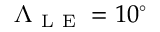<formula> <loc_0><loc_0><loc_500><loc_500>\Lambda _ { L E } = 1 0 ^ { \circ }</formula> 